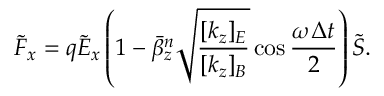<formula> <loc_0><loc_0><loc_500><loc_500>\tilde { F } _ { x } = q \tilde { E } _ { x } \left ( 1 - \bar { \beta } _ { z } ^ { n } \sqrt { \frac { [ k _ { z } ] _ { E } } { [ k _ { z } ] _ { B } } } \cos \frac { \omega \Delta t } { 2 } \right ) \tilde { S } .</formula> 